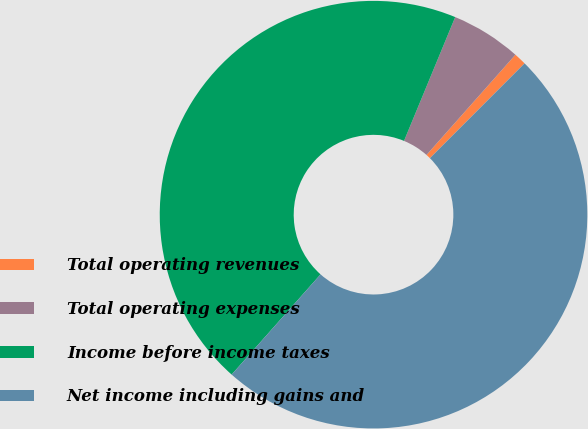<chart> <loc_0><loc_0><loc_500><loc_500><pie_chart><fcel>Total operating revenues<fcel>Total operating expenses<fcel>Income before income taxes<fcel>Net income including gains and<nl><fcel>0.94%<fcel>5.31%<fcel>44.69%<fcel>49.06%<nl></chart> 